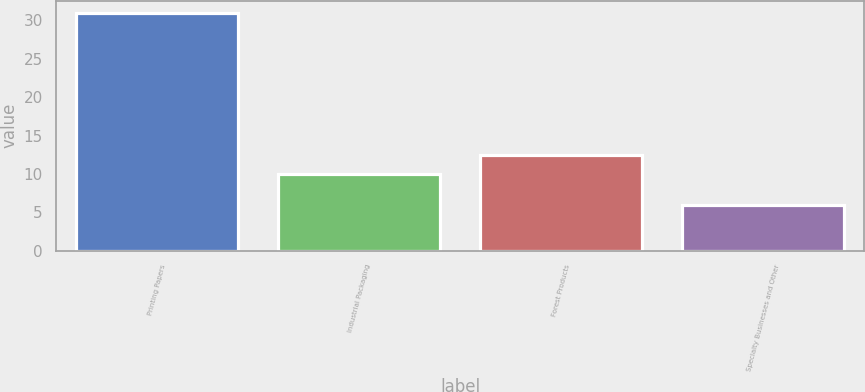<chart> <loc_0><loc_0><loc_500><loc_500><bar_chart><fcel>Printing Papers<fcel>Industrial Packaging<fcel>Forest Products<fcel>Specialty Businesses and Other<nl><fcel>31<fcel>10<fcel>12.5<fcel>6<nl></chart> 